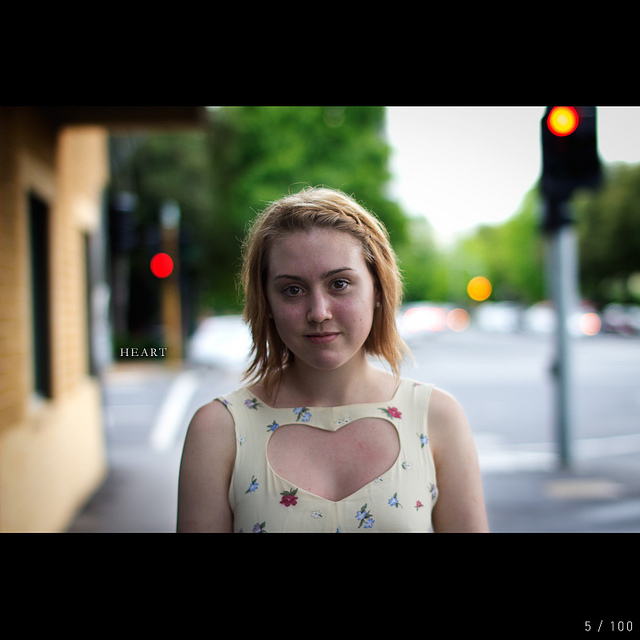Please identify all text content in this image. HEART 100 5 